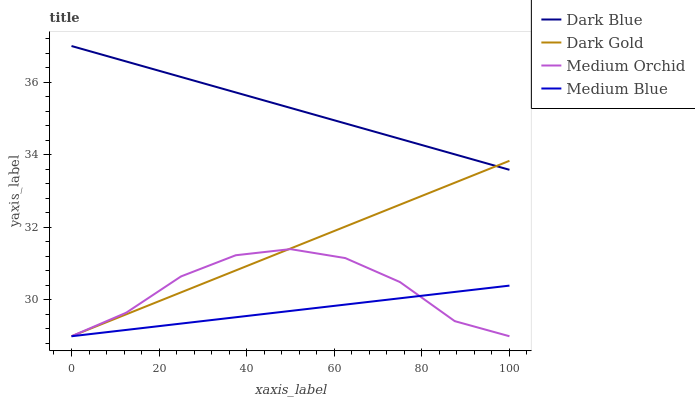Does Medium Blue have the minimum area under the curve?
Answer yes or no. Yes. Does Dark Blue have the maximum area under the curve?
Answer yes or no. Yes. Does Medium Orchid have the minimum area under the curve?
Answer yes or no. No. Does Medium Orchid have the maximum area under the curve?
Answer yes or no. No. Is Medium Blue the smoothest?
Answer yes or no. Yes. Is Medium Orchid the roughest?
Answer yes or no. Yes. Is Medium Orchid the smoothest?
Answer yes or no. No. Is Medium Blue the roughest?
Answer yes or no. No. Does Medium Orchid have the lowest value?
Answer yes or no. Yes. Does Dark Blue have the highest value?
Answer yes or no. Yes. Does Medium Orchid have the highest value?
Answer yes or no. No. Is Medium Blue less than Dark Blue?
Answer yes or no. Yes. Is Dark Blue greater than Medium Orchid?
Answer yes or no. Yes. Does Medium Blue intersect Medium Orchid?
Answer yes or no. Yes. Is Medium Blue less than Medium Orchid?
Answer yes or no. No. Is Medium Blue greater than Medium Orchid?
Answer yes or no. No. Does Medium Blue intersect Dark Blue?
Answer yes or no. No. 